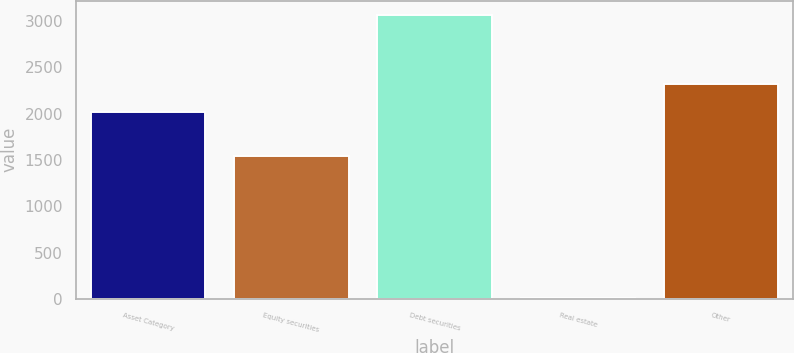Convert chart. <chart><loc_0><loc_0><loc_500><loc_500><bar_chart><fcel>Asset Category<fcel>Equity securities<fcel>Debt securities<fcel>Real estate<fcel>Other<nl><fcel>2017<fcel>1545<fcel>3065<fcel>10<fcel>2322.5<nl></chart> 